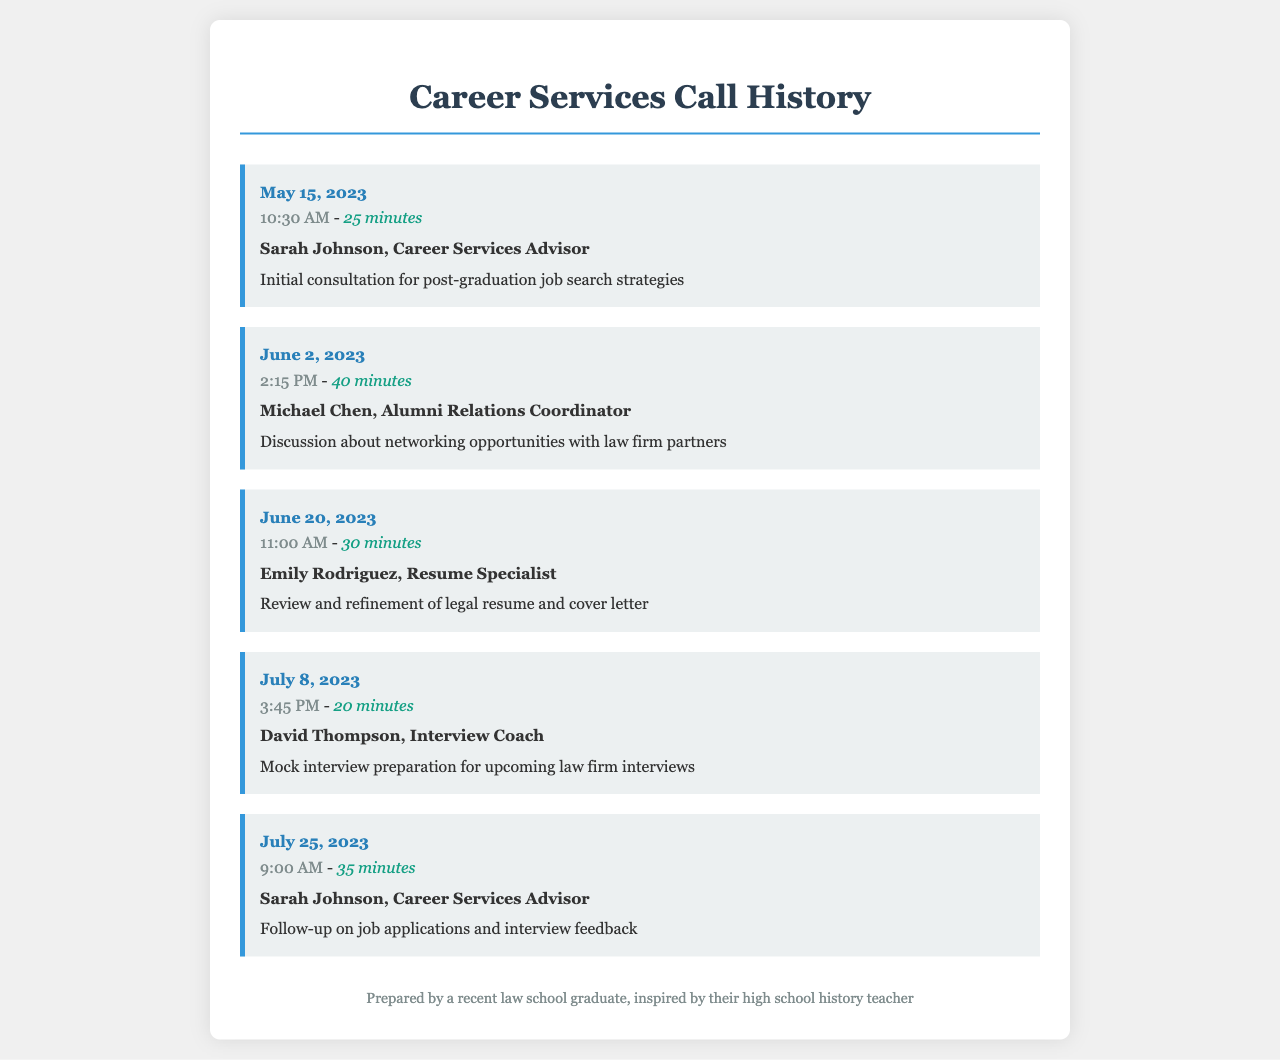What is the date of the initial consultation? The initial consultation took place on May 15, 2023.
Answer: May 15, 2023 Who was the Career Services Advisor contacted on July 25, 2023? The Career Services Advisor contacted on this date was Sarah Johnson.
Answer: Sarah Johnson How long was the call on June 2, 2023? The call on June 2, 2023, lasted for 40 minutes.
Answer: 40 minutes What was the purpose of the call made on July 8, 2023? The purpose of the call was mock interview preparation for upcoming law firm interviews.
Answer: Mock interview preparation On which date was the resume review conducted? The resume review was conducted on June 20, 2023.
Answer: June 20, 2023 How many total consultations were conducted with Sarah Johnson? A total of two consultations were conducted with Sarah Johnson.
Answer: 2 What time was the discussion about networking opportunities scheduled? The discussion about networking opportunities was scheduled for 2:15 PM.
Answer: 2:15 PM Which specialist reviewed the legal resume? The specialist who reviewed the legal resume was Emily Rodriguez.
Answer: Emily Rodriguez 